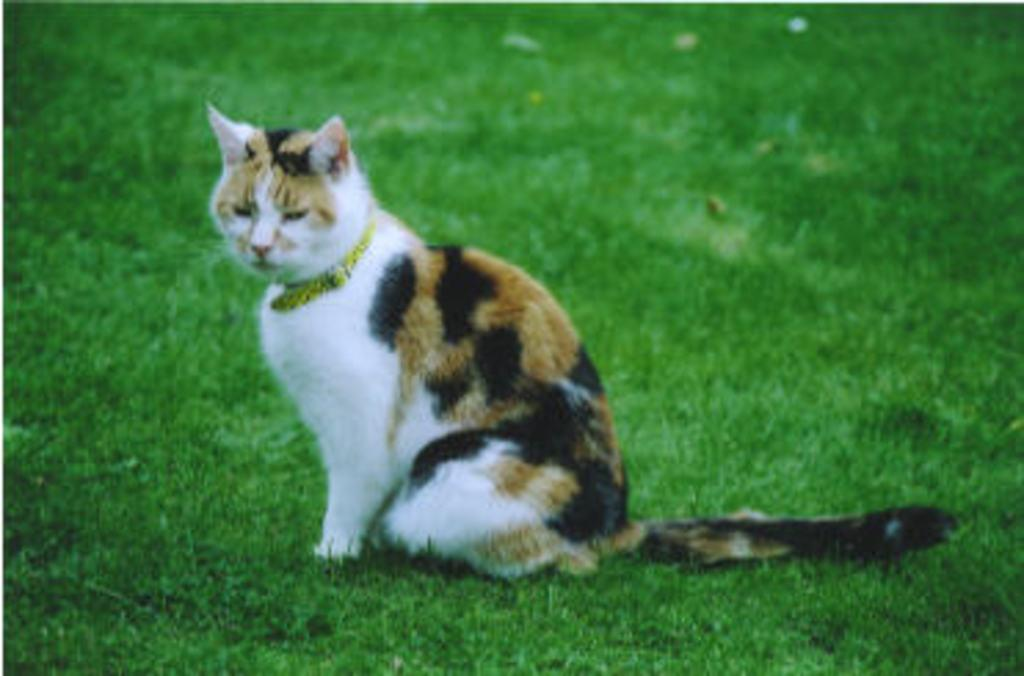What type of animal is in the image? There is a cat in the image. Can you describe the color of the cat? The cat is white and brown in color. What type of vegetation is visible at the bottom of the image? There is green grass at the bottom of the image. What type of ocean waves can be seen in the image? There is no ocean or waves present in the image; it features a cat and green grass. What type of linen is draped over the cat in the image? There is no linen present in the image; the cat is not covered by any fabric. 